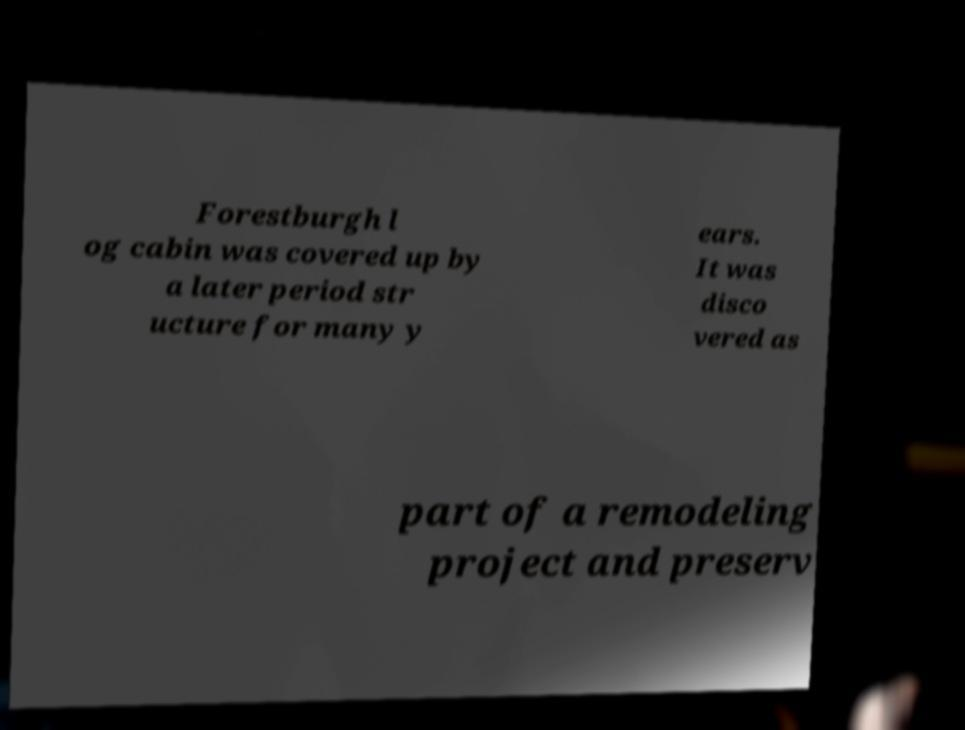Please read and relay the text visible in this image. What does it say? Forestburgh l og cabin was covered up by a later period str ucture for many y ears. It was disco vered as part of a remodeling project and preserv 